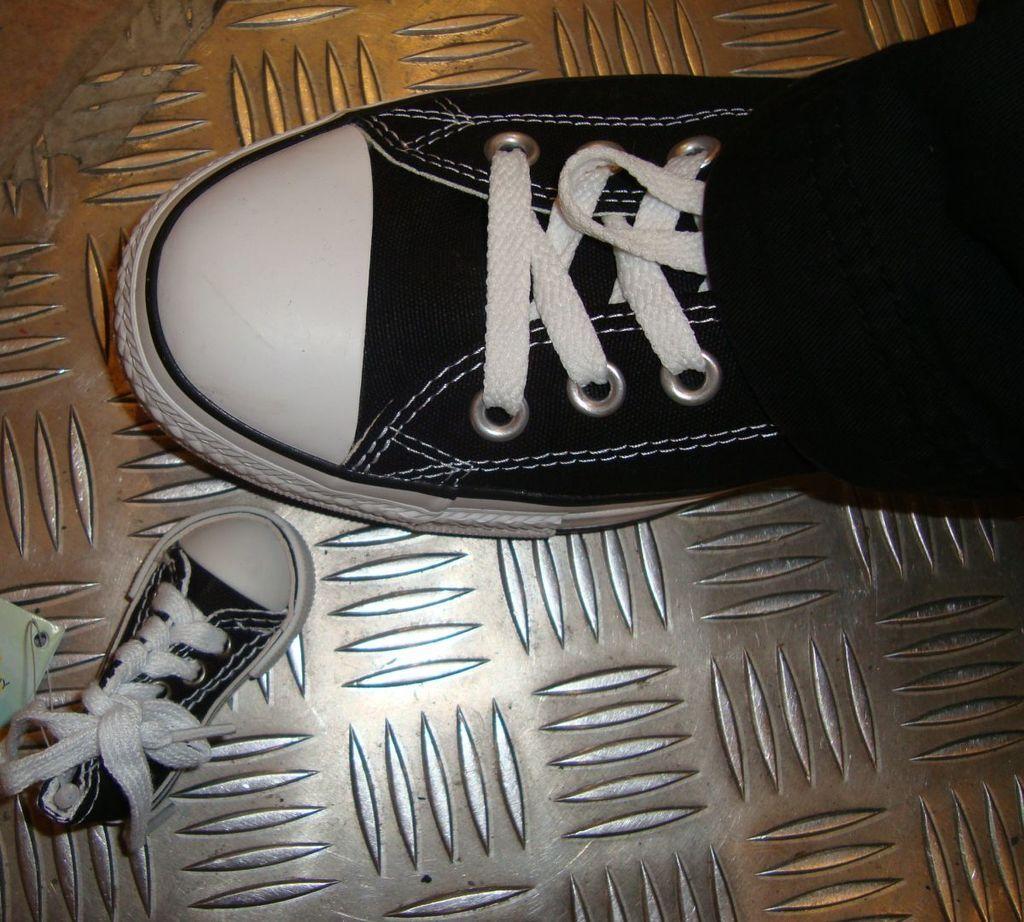Can you describe this image briefly? This picture shows a human wore a big size shoe and we see a small size shoe on the side. Both are white and black in color. 